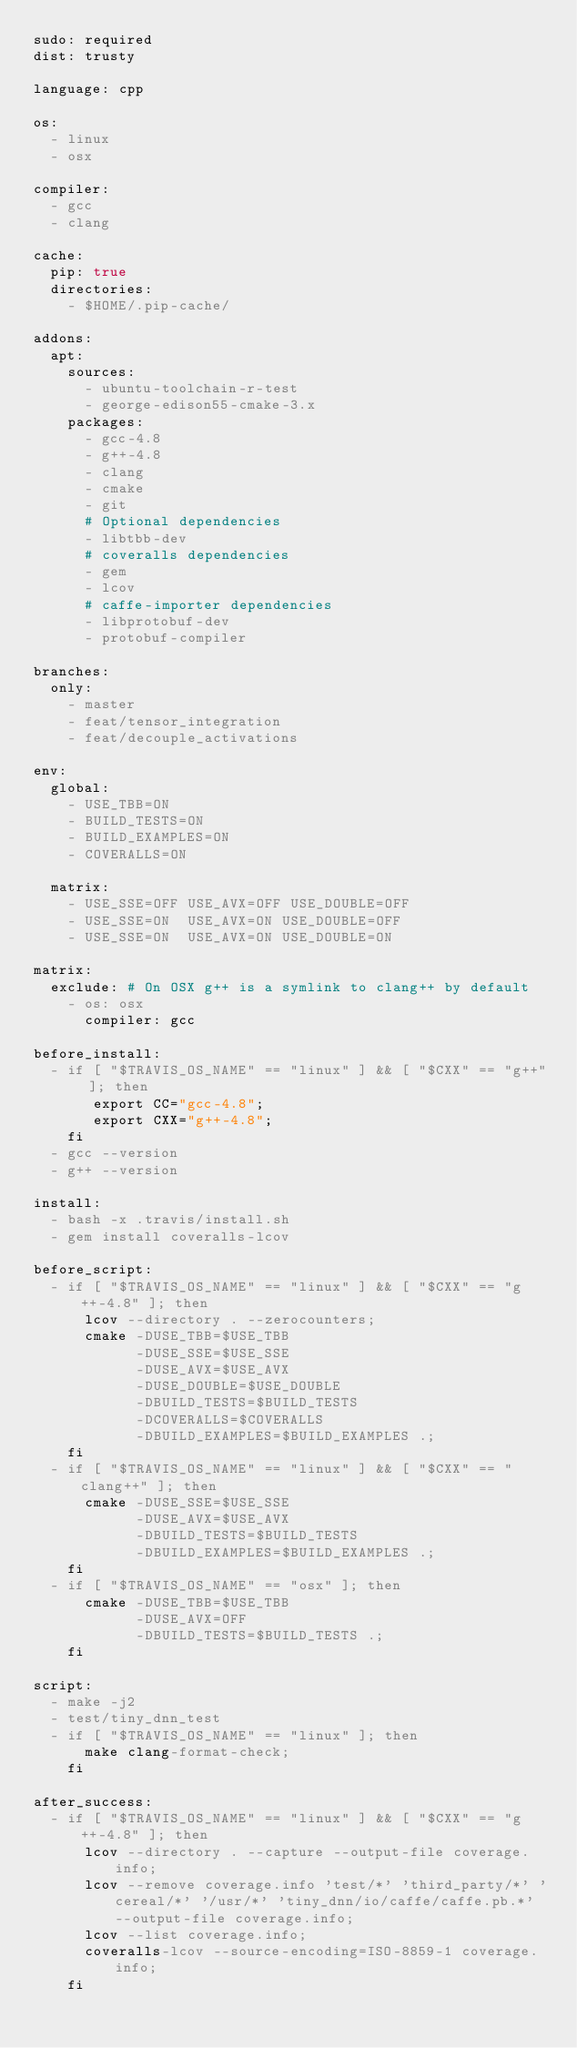Convert code to text. <code><loc_0><loc_0><loc_500><loc_500><_YAML_>sudo: required
dist: trusty

language: cpp

os:
  - linux
  - osx

compiler:
  - gcc
  - clang

cache:
  pip: true
  directories:
    - $HOME/.pip-cache/

addons:
  apt:
    sources:
      - ubuntu-toolchain-r-test
      - george-edison55-cmake-3.x
    packages:
      - gcc-4.8
      - g++-4.8
      - clang
      - cmake
      - git
      # Optional dependencies
      - libtbb-dev
      # coveralls dependencies
      - gem
      - lcov
      # caffe-importer dependencies
      - libprotobuf-dev
      - protobuf-compiler

branches:
  only:
    - master
    - feat/tensor_integration
    - feat/decouple_activations

env:
  global:
    - USE_TBB=ON
    - BUILD_TESTS=ON
    - BUILD_EXAMPLES=ON
    - COVERALLS=ON

  matrix:
    - USE_SSE=OFF USE_AVX=OFF USE_DOUBLE=OFF
    - USE_SSE=ON  USE_AVX=ON USE_DOUBLE=OFF
    - USE_SSE=ON  USE_AVX=ON USE_DOUBLE=ON

matrix:
  exclude: # On OSX g++ is a symlink to clang++ by default
    - os: osx
      compiler: gcc

before_install:
  - if [ "$TRAVIS_OS_NAME" == "linux" ] && [ "$CXX" == "g++" ]; then
       export CC="gcc-4.8";
       export CXX="g++-4.8";
    fi
  - gcc --version
  - g++ --version

install:
  - bash -x .travis/install.sh
  - gem install coveralls-lcov

before_script:
  - if [ "$TRAVIS_OS_NAME" == "linux" ] && [ "$CXX" == "g++-4.8" ]; then
      lcov --directory . --zerocounters;
      cmake -DUSE_TBB=$USE_TBB
            -DUSE_SSE=$USE_SSE
            -DUSE_AVX=$USE_AVX
            -DUSE_DOUBLE=$USE_DOUBLE
            -DBUILD_TESTS=$BUILD_TESTS
            -DCOVERALLS=$COVERALLS
            -DBUILD_EXAMPLES=$BUILD_EXAMPLES .;
    fi
  - if [ "$TRAVIS_OS_NAME" == "linux" ] && [ "$CXX" == "clang++" ]; then
      cmake -DUSE_SSE=$USE_SSE
            -DUSE_AVX=$USE_AVX
            -DBUILD_TESTS=$BUILD_TESTS
            -DBUILD_EXAMPLES=$BUILD_EXAMPLES .;
    fi
  - if [ "$TRAVIS_OS_NAME" == "osx" ]; then
      cmake -DUSE_TBB=$USE_TBB
            -DUSE_AVX=OFF
            -DBUILD_TESTS=$BUILD_TESTS .;
    fi

script:
  - make -j2
  - test/tiny_dnn_test
  - if [ "$TRAVIS_OS_NAME" == "linux" ]; then
      make clang-format-check;
    fi

after_success:
  - if [ "$TRAVIS_OS_NAME" == "linux" ] && [ "$CXX" == "g++-4.8" ]; then
      lcov --directory . --capture --output-file coverage.info;
      lcov --remove coverage.info 'test/*' 'third_party/*' 'cereal/*' '/usr/*' 'tiny_dnn/io/caffe/caffe.pb.*' --output-file coverage.info;
      lcov --list coverage.info;
      coveralls-lcov --source-encoding=ISO-8859-1 coverage.info;
    fi
</code> 